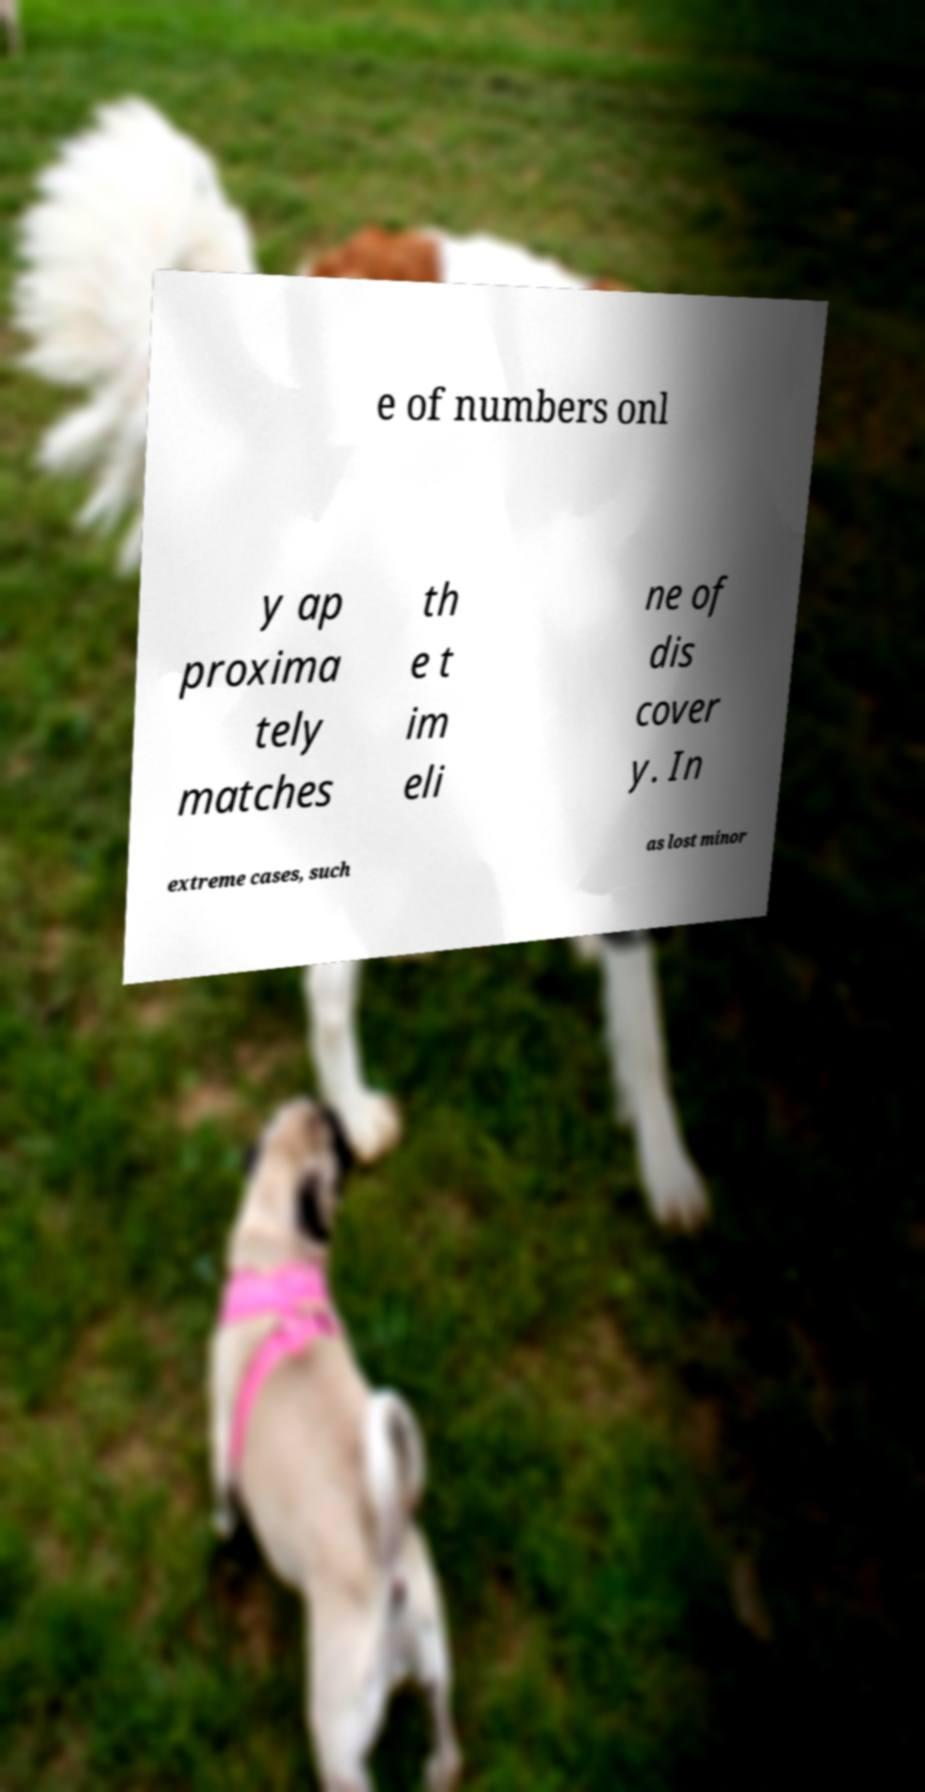There's text embedded in this image that I need extracted. Can you transcribe it verbatim? e of numbers onl y ap proxima tely matches th e t im eli ne of dis cover y. In extreme cases, such as lost minor 